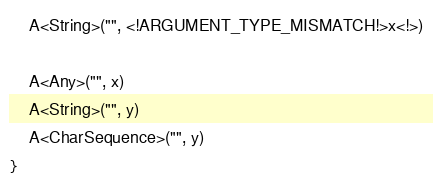Convert code to text. <code><loc_0><loc_0><loc_500><loc_500><_Kotlin_>
    A<String>("", <!ARGUMENT_TYPE_MISMATCH!>x<!>)

    A<Any>("", x)
    A<String>("", y)
    A<CharSequence>("", y)
}
</code> 